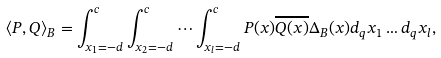Convert formula to latex. <formula><loc_0><loc_0><loc_500><loc_500>\langle P , Q \rangle _ { B } = \int _ { x _ { 1 } = - d } ^ { c } \int _ { x _ { 2 } = - d } ^ { c } \cdots \int _ { x _ { l } = - d } ^ { c } P ( x ) \overline { Q ( x ) } \Delta _ { B } ( x ) d _ { q } x _ { 1 } \dots d _ { q } x _ { l } ,</formula> 